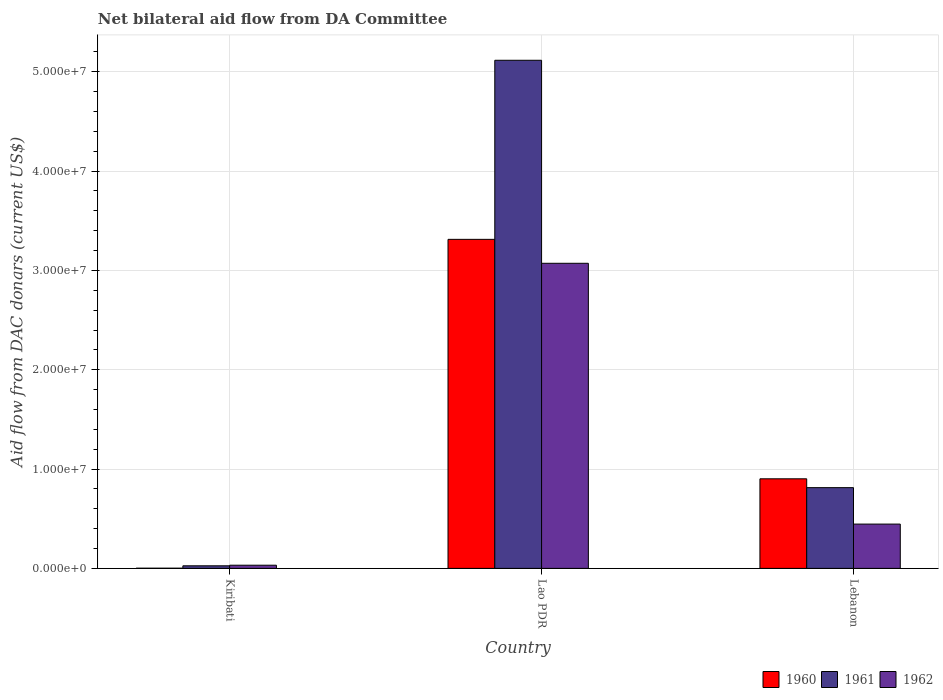How many different coloured bars are there?
Make the answer very short. 3. How many groups of bars are there?
Provide a short and direct response. 3. Are the number of bars per tick equal to the number of legend labels?
Your answer should be compact. Yes. Are the number of bars on each tick of the X-axis equal?
Your answer should be very brief. Yes. How many bars are there on the 3rd tick from the left?
Offer a very short reply. 3. How many bars are there on the 2nd tick from the right?
Make the answer very short. 3. What is the label of the 2nd group of bars from the left?
Make the answer very short. Lao PDR. What is the aid flow in in 1961 in Lebanon?
Offer a very short reply. 8.13e+06. Across all countries, what is the maximum aid flow in in 1960?
Ensure brevity in your answer.  3.31e+07. In which country was the aid flow in in 1960 maximum?
Give a very brief answer. Lao PDR. In which country was the aid flow in in 1962 minimum?
Make the answer very short. Kiribati. What is the total aid flow in in 1962 in the graph?
Offer a terse response. 3.55e+07. What is the difference between the aid flow in in 1961 in Kiribati and that in Lao PDR?
Ensure brevity in your answer.  -5.09e+07. What is the difference between the aid flow in in 1960 in Lao PDR and the aid flow in in 1961 in Lebanon?
Provide a short and direct response. 2.50e+07. What is the average aid flow in in 1960 per country?
Make the answer very short. 1.41e+07. What is the difference between the aid flow in of/in 1961 and aid flow in of/in 1962 in Lebanon?
Provide a short and direct response. 3.67e+06. What is the ratio of the aid flow in in 1961 in Kiribati to that in Lebanon?
Keep it short and to the point. 0.03. Is the difference between the aid flow in in 1961 in Lao PDR and Lebanon greater than the difference between the aid flow in in 1962 in Lao PDR and Lebanon?
Your answer should be compact. Yes. What is the difference between the highest and the second highest aid flow in in 1961?
Keep it short and to the point. 5.09e+07. What is the difference between the highest and the lowest aid flow in in 1961?
Provide a succinct answer. 5.09e+07. In how many countries, is the aid flow in in 1961 greater than the average aid flow in in 1961 taken over all countries?
Keep it short and to the point. 1. What does the 1st bar from the left in Lebanon represents?
Keep it short and to the point. 1960. Is it the case that in every country, the sum of the aid flow in in 1960 and aid flow in in 1961 is greater than the aid flow in in 1962?
Ensure brevity in your answer.  No. How many bars are there?
Offer a very short reply. 9. How many countries are there in the graph?
Ensure brevity in your answer.  3. Does the graph contain any zero values?
Provide a succinct answer. No. Does the graph contain grids?
Your response must be concise. Yes. How many legend labels are there?
Make the answer very short. 3. How are the legend labels stacked?
Your answer should be compact. Horizontal. What is the title of the graph?
Your response must be concise. Net bilateral aid flow from DA Committee. What is the label or title of the Y-axis?
Your answer should be very brief. Aid flow from DAC donars (current US$). What is the Aid flow from DAC donars (current US$) of 1961 in Kiribati?
Make the answer very short. 2.60e+05. What is the Aid flow from DAC donars (current US$) of 1960 in Lao PDR?
Offer a terse response. 3.31e+07. What is the Aid flow from DAC donars (current US$) in 1961 in Lao PDR?
Keep it short and to the point. 5.12e+07. What is the Aid flow from DAC donars (current US$) in 1962 in Lao PDR?
Provide a short and direct response. 3.07e+07. What is the Aid flow from DAC donars (current US$) in 1960 in Lebanon?
Your answer should be compact. 9.02e+06. What is the Aid flow from DAC donars (current US$) in 1961 in Lebanon?
Offer a very short reply. 8.13e+06. What is the Aid flow from DAC donars (current US$) in 1962 in Lebanon?
Provide a succinct answer. 4.46e+06. Across all countries, what is the maximum Aid flow from DAC donars (current US$) of 1960?
Your answer should be very brief. 3.31e+07. Across all countries, what is the maximum Aid flow from DAC donars (current US$) in 1961?
Your response must be concise. 5.12e+07. Across all countries, what is the maximum Aid flow from DAC donars (current US$) of 1962?
Your answer should be very brief. 3.07e+07. Across all countries, what is the minimum Aid flow from DAC donars (current US$) of 1960?
Your answer should be very brief. 2.00e+04. Across all countries, what is the minimum Aid flow from DAC donars (current US$) of 1961?
Give a very brief answer. 2.60e+05. What is the total Aid flow from DAC donars (current US$) of 1960 in the graph?
Give a very brief answer. 4.22e+07. What is the total Aid flow from DAC donars (current US$) in 1961 in the graph?
Ensure brevity in your answer.  5.96e+07. What is the total Aid flow from DAC donars (current US$) of 1962 in the graph?
Your response must be concise. 3.55e+07. What is the difference between the Aid flow from DAC donars (current US$) of 1960 in Kiribati and that in Lao PDR?
Offer a very short reply. -3.31e+07. What is the difference between the Aid flow from DAC donars (current US$) in 1961 in Kiribati and that in Lao PDR?
Your response must be concise. -5.09e+07. What is the difference between the Aid flow from DAC donars (current US$) in 1962 in Kiribati and that in Lao PDR?
Offer a terse response. -3.04e+07. What is the difference between the Aid flow from DAC donars (current US$) in 1960 in Kiribati and that in Lebanon?
Offer a very short reply. -9.00e+06. What is the difference between the Aid flow from DAC donars (current US$) of 1961 in Kiribati and that in Lebanon?
Provide a short and direct response. -7.87e+06. What is the difference between the Aid flow from DAC donars (current US$) in 1962 in Kiribati and that in Lebanon?
Your answer should be very brief. -4.14e+06. What is the difference between the Aid flow from DAC donars (current US$) in 1960 in Lao PDR and that in Lebanon?
Offer a terse response. 2.41e+07. What is the difference between the Aid flow from DAC donars (current US$) of 1961 in Lao PDR and that in Lebanon?
Keep it short and to the point. 4.30e+07. What is the difference between the Aid flow from DAC donars (current US$) of 1962 in Lao PDR and that in Lebanon?
Offer a very short reply. 2.63e+07. What is the difference between the Aid flow from DAC donars (current US$) of 1960 in Kiribati and the Aid flow from DAC donars (current US$) of 1961 in Lao PDR?
Your answer should be compact. -5.11e+07. What is the difference between the Aid flow from DAC donars (current US$) of 1960 in Kiribati and the Aid flow from DAC donars (current US$) of 1962 in Lao PDR?
Provide a short and direct response. -3.07e+07. What is the difference between the Aid flow from DAC donars (current US$) of 1961 in Kiribati and the Aid flow from DAC donars (current US$) of 1962 in Lao PDR?
Offer a terse response. -3.05e+07. What is the difference between the Aid flow from DAC donars (current US$) in 1960 in Kiribati and the Aid flow from DAC donars (current US$) in 1961 in Lebanon?
Provide a succinct answer. -8.11e+06. What is the difference between the Aid flow from DAC donars (current US$) in 1960 in Kiribati and the Aid flow from DAC donars (current US$) in 1962 in Lebanon?
Ensure brevity in your answer.  -4.44e+06. What is the difference between the Aid flow from DAC donars (current US$) of 1961 in Kiribati and the Aid flow from DAC donars (current US$) of 1962 in Lebanon?
Provide a short and direct response. -4.20e+06. What is the difference between the Aid flow from DAC donars (current US$) of 1960 in Lao PDR and the Aid flow from DAC donars (current US$) of 1961 in Lebanon?
Provide a succinct answer. 2.50e+07. What is the difference between the Aid flow from DAC donars (current US$) of 1960 in Lao PDR and the Aid flow from DAC donars (current US$) of 1962 in Lebanon?
Offer a terse response. 2.87e+07. What is the difference between the Aid flow from DAC donars (current US$) of 1961 in Lao PDR and the Aid flow from DAC donars (current US$) of 1962 in Lebanon?
Give a very brief answer. 4.67e+07. What is the average Aid flow from DAC donars (current US$) of 1960 per country?
Make the answer very short. 1.41e+07. What is the average Aid flow from DAC donars (current US$) in 1961 per country?
Your response must be concise. 1.98e+07. What is the average Aid flow from DAC donars (current US$) in 1962 per country?
Ensure brevity in your answer.  1.18e+07. What is the difference between the Aid flow from DAC donars (current US$) of 1960 and Aid flow from DAC donars (current US$) of 1961 in Lao PDR?
Your response must be concise. -1.80e+07. What is the difference between the Aid flow from DAC donars (current US$) in 1960 and Aid flow from DAC donars (current US$) in 1962 in Lao PDR?
Make the answer very short. 2.41e+06. What is the difference between the Aid flow from DAC donars (current US$) in 1961 and Aid flow from DAC donars (current US$) in 1962 in Lao PDR?
Provide a succinct answer. 2.04e+07. What is the difference between the Aid flow from DAC donars (current US$) in 1960 and Aid flow from DAC donars (current US$) in 1961 in Lebanon?
Provide a succinct answer. 8.90e+05. What is the difference between the Aid flow from DAC donars (current US$) in 1960 and Aid flow from DAC donars (current US$) in 1962 in Lebanon?
Your answer should be compact. 4.56e+06. What is the difference between the Aid flow from DAC donars (current US$) in 1961 and Aid flow from DAC donars (current US$) in 1962 in Lebanon?
Your response must be concise. 3.67e+06. What is the ratio of the Aid flow from DAC donars (current US$) in 1960 in Kiribati to that in Lao PDR?
Make the answer very short. 0. What is the ratio of the Aid flow from DAC donars (current US$) in 1961 in Kiribati to that in Lao PDR?
Ensure brevity in your answer.  0.01. What is the ratio of the Aid flow from DAC donars (current US$) of 1962 in Kiribati to that in Lao PDR?
Offer a very short reply. 0.01. What is the ratio of the Aid flow from DAC donars (current US$) of 1960 in Kiribati to that in Lebanon?
Offer a terse response. 0. What is the ratio of the Aid flow from DAC donars (current US$) in 1961 in Kiribati to that in Lebanon?
Provide a succinct answer. 0.03. What is the ratio of the Aid flow from DAC donars (current US$) of 1962 in Kiribati to that in Lebanon?
Your answer should be very brief. 0.07. What is the ratio of the Aid flow from DAC donars (current US$) in 1960 in Lao PDR to that in Lebanon?
Give a very brief answer. 3.67. What is the ratio of the Aid flow from DAC donars (current US$) in 1961 in Lao PDR to that in Lebanon?
Offer a terse response. 6.29. What is the ratio of the Aid flow from DAC donars (current US$) of 1962 in Lao PDR to that in Lebanon?
Ensure brevity in your answer.  6.89. What is the difference between the highest and the second highest Aid flow from DAC donars (current US$) of 1960?
Ensure brevity in your answer.  2.41e+07. What is the difference between the highest and the second highest Aid flow from DAC donars (current US$) of 1961?
Ensure brevity in your answer.  4.30e+07. What is the difference between the highest and the second highest Aid flow from DAC donars (current US$) in 1962?
Offer a very short reply. 2.63e+07. What is the difference between the highest and the lowest Aid flow from DAC donars (current US$) in 1960?
Provide a succinct answer. 3.31e+07. What is the difference between the highest and the lowest Aid flow from DAC donars (current US$) in 1961?
Make the answer very short. 5.09e+07. What is the difference between the highest and the lowest Aid flow from DAC donars (current US$) of 1962?
Provide a succinct answer. 3.04e+07. 